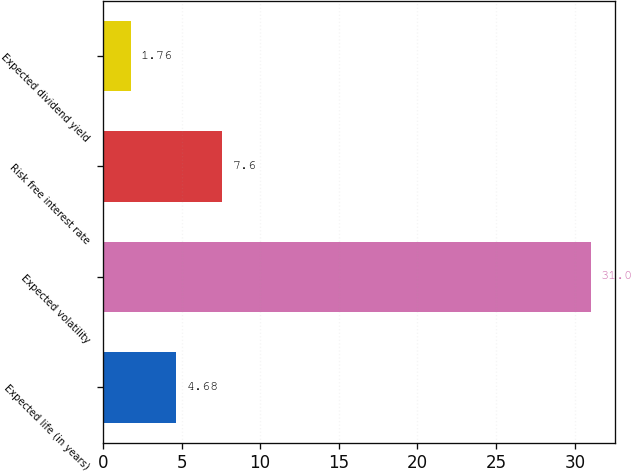Convert chart. <chart><loc_0><loc_0><loc_500><loc_500><bar_chart><fcel>Expected life (in years)<fcel>Expected volatility<fcel>Risk free interest rate<fcel>Expected dividend yield<nl><fcel>4.68<fcel>31<fcel>7.6<fcel>1.76<nl></chart> 